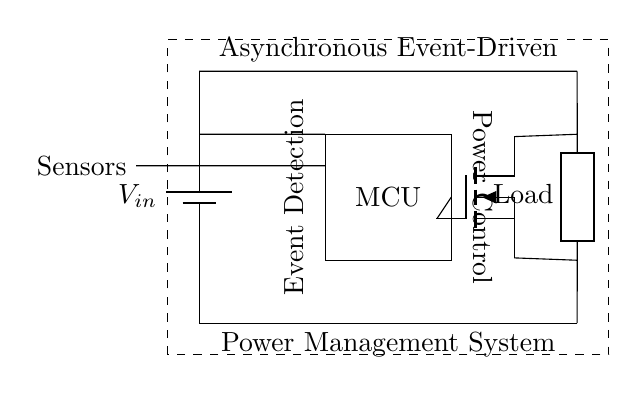What is the main component responsible for power control in this circuit? The power control in the circuit is managed by the MOSFET, which is a type of transistor that regulates the flow of electricity to the load.
Answer: MOSFET What type of circuit is represented by this diagram? This is an asynchronous event-driven power management system, designed to reduce energy consumption by turning off machinery that is idle.
Answer: Asynchronous event-driven How many input sensors are indicated in the circuit? The circuit diagram shows one line indicating the presence of sensors, which suggests there are multiple sensors providing input to the microcontroller, but the specific number isn't depicted.
Answer: Multiple What is the voltage source in this circuit? The battery is indicated as the voltage source for the circuit, providing the necessary electrical power for operation.
Answer: Battery What does the dashed rectangle represent in the diagram? The dashed rectangle encircles the entire circuit, signifying it as a complete system. It acts as a boundary to distinguish the components and their functioning within the broader context of the whole system.
Answer: Complete system Which direction do the current flows from the voltage source? Current flows from the positive terminal of the battery down through the circuit towards the load, completing the path through the defined connections.
Answer: Downwards What role does the microcontroller play in this circuit? The microcontroller receives input signals from the sensors and manages the operation of the MOSFET based on those signals, acting as the brain of the system to adjust the power supply.
Answer: Controls power management 